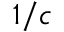<formula> <loc_0><loc_0><loc_500><loc_500>1 / c</formula> 